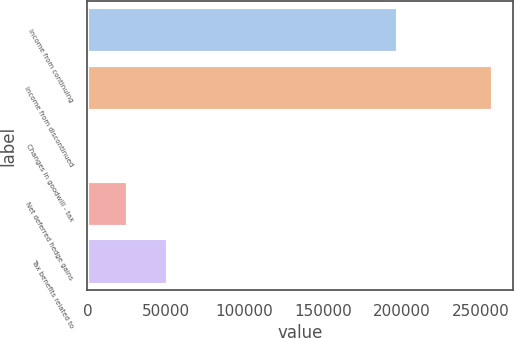Convert chart to OTSL. <chart><loc_0><loc_0><loc_500><loc_500><bar_chart><fcel>Income from continuing<fcel>Income from discontinued<fcel>Changes in goodwill - tax<fcel>Net deferred hedge gains<fcel>Tax benefits related to<nl><fcel>197644<fcel>257950<fcel>40<fcel>25831<fcel>51622<nl></chart> 